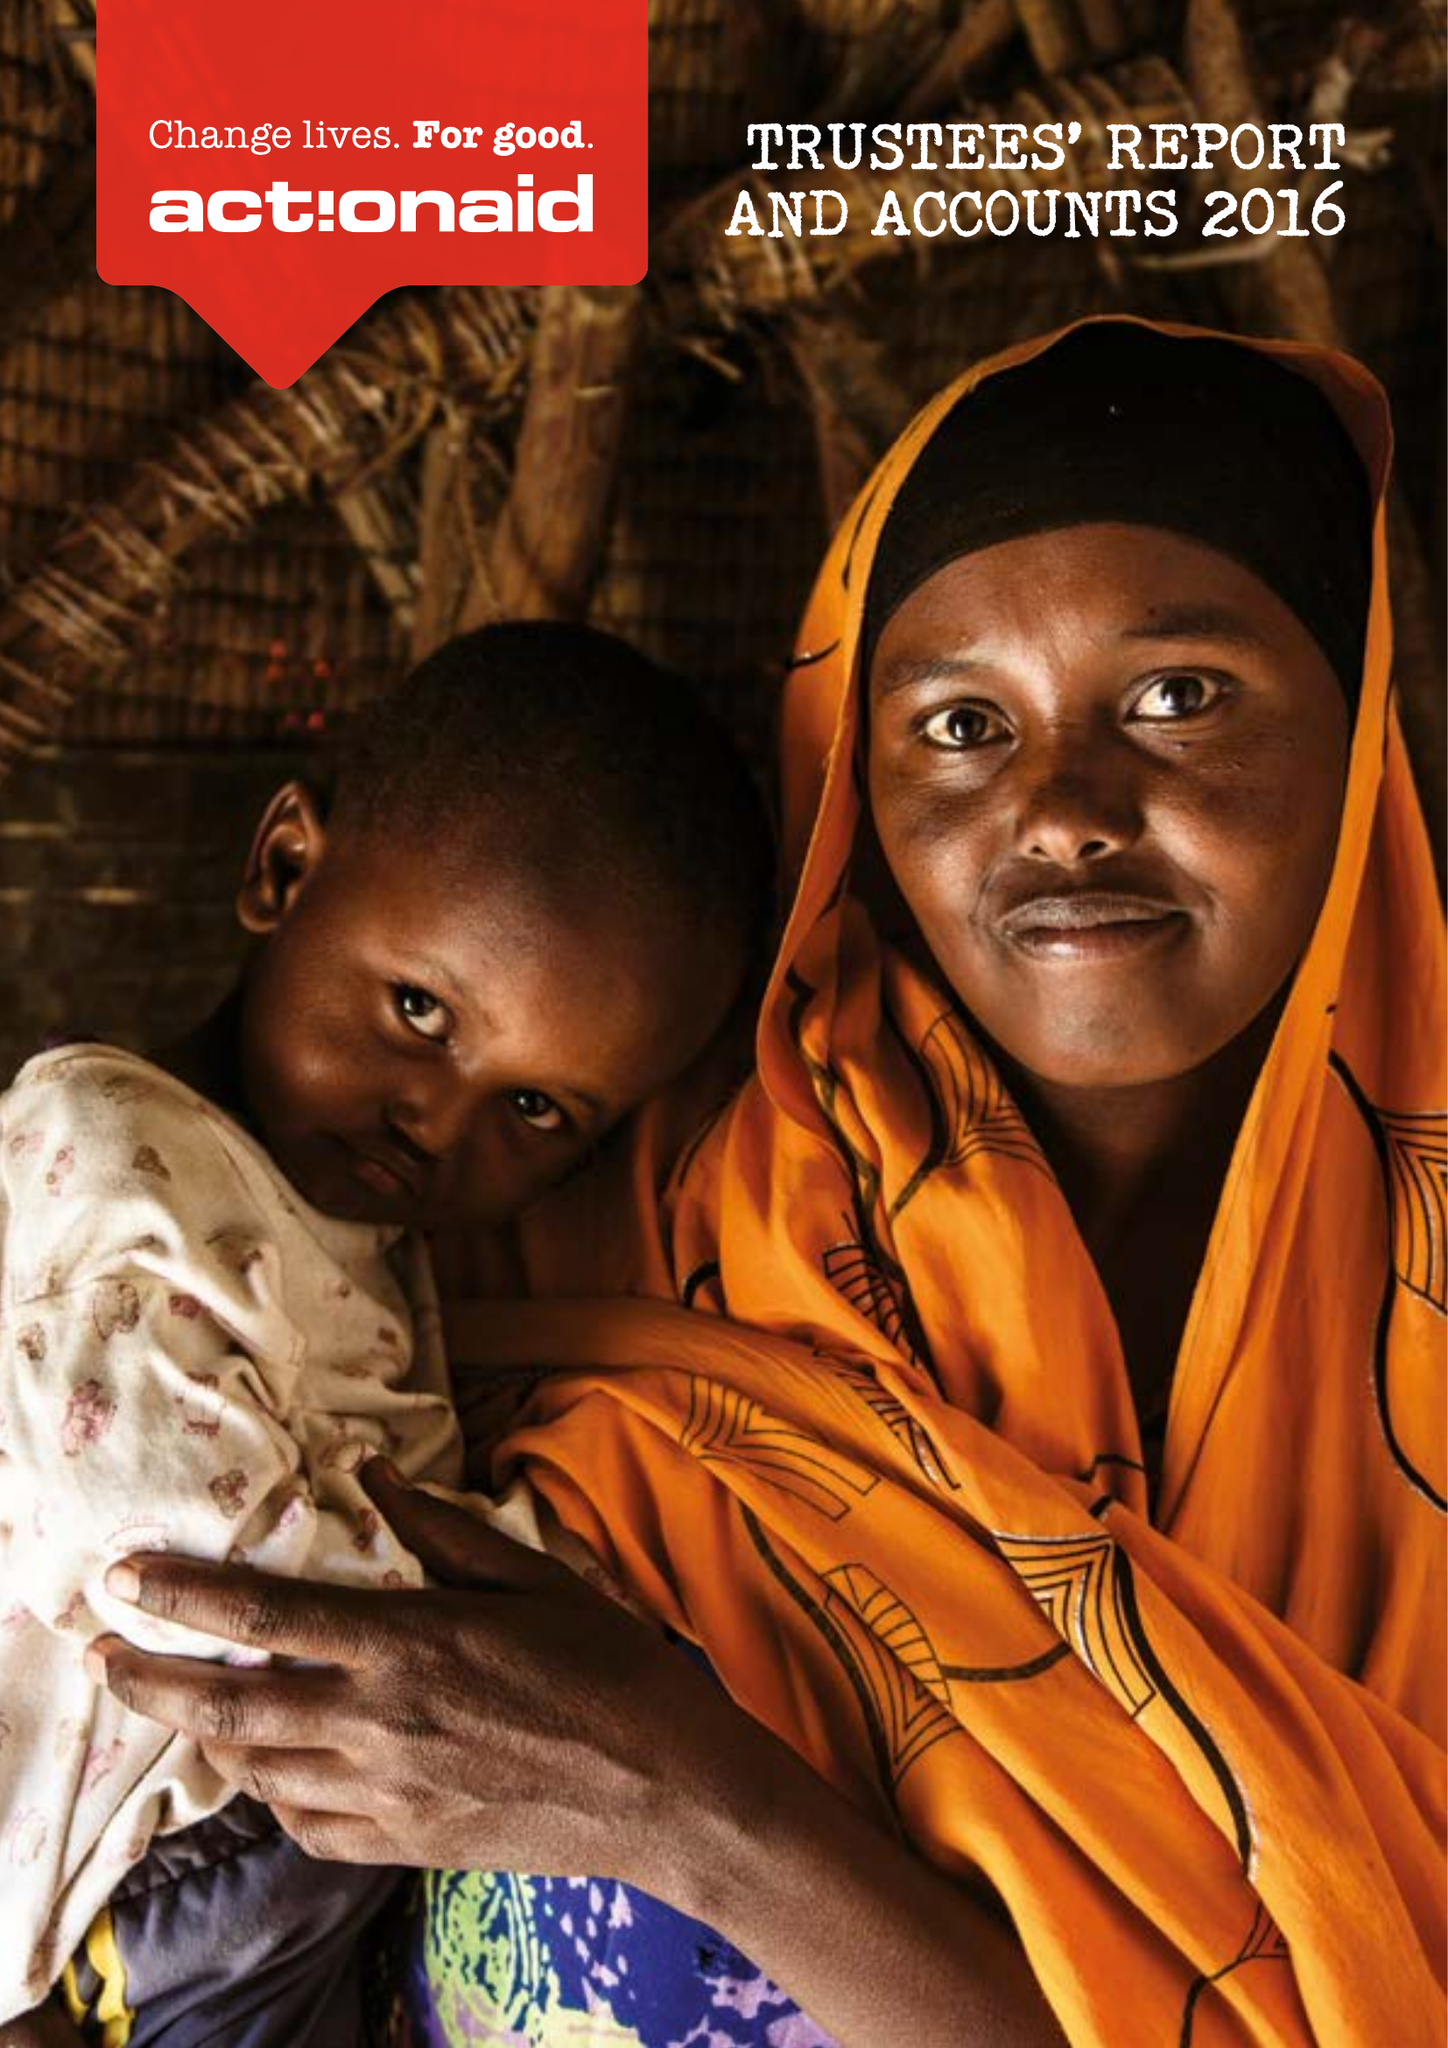What is the value for the charity_name?
Answer the question using a single word or phrase. Actionaid 